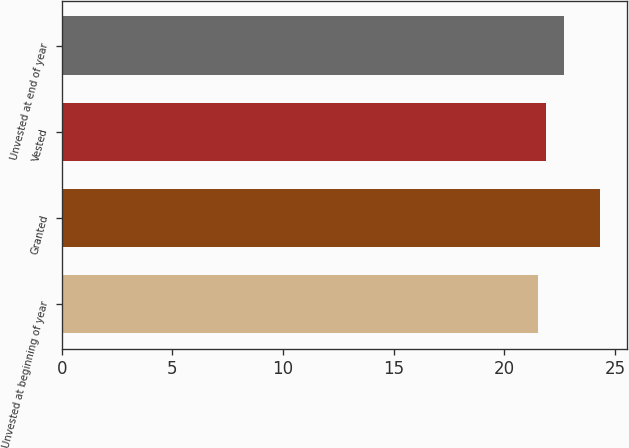Convert chart to OTSL. <chart><loc_0><loc_0><loc_500><loc_500><bar_chart><fcel>Unvested at beginning of year<fcel>Granted<fcel>Vested<fcel>Unvested at end of year<nl><fcel>21.53<fcel>24.31<fcel>21.86<fcel>22.69<nl></chart> 